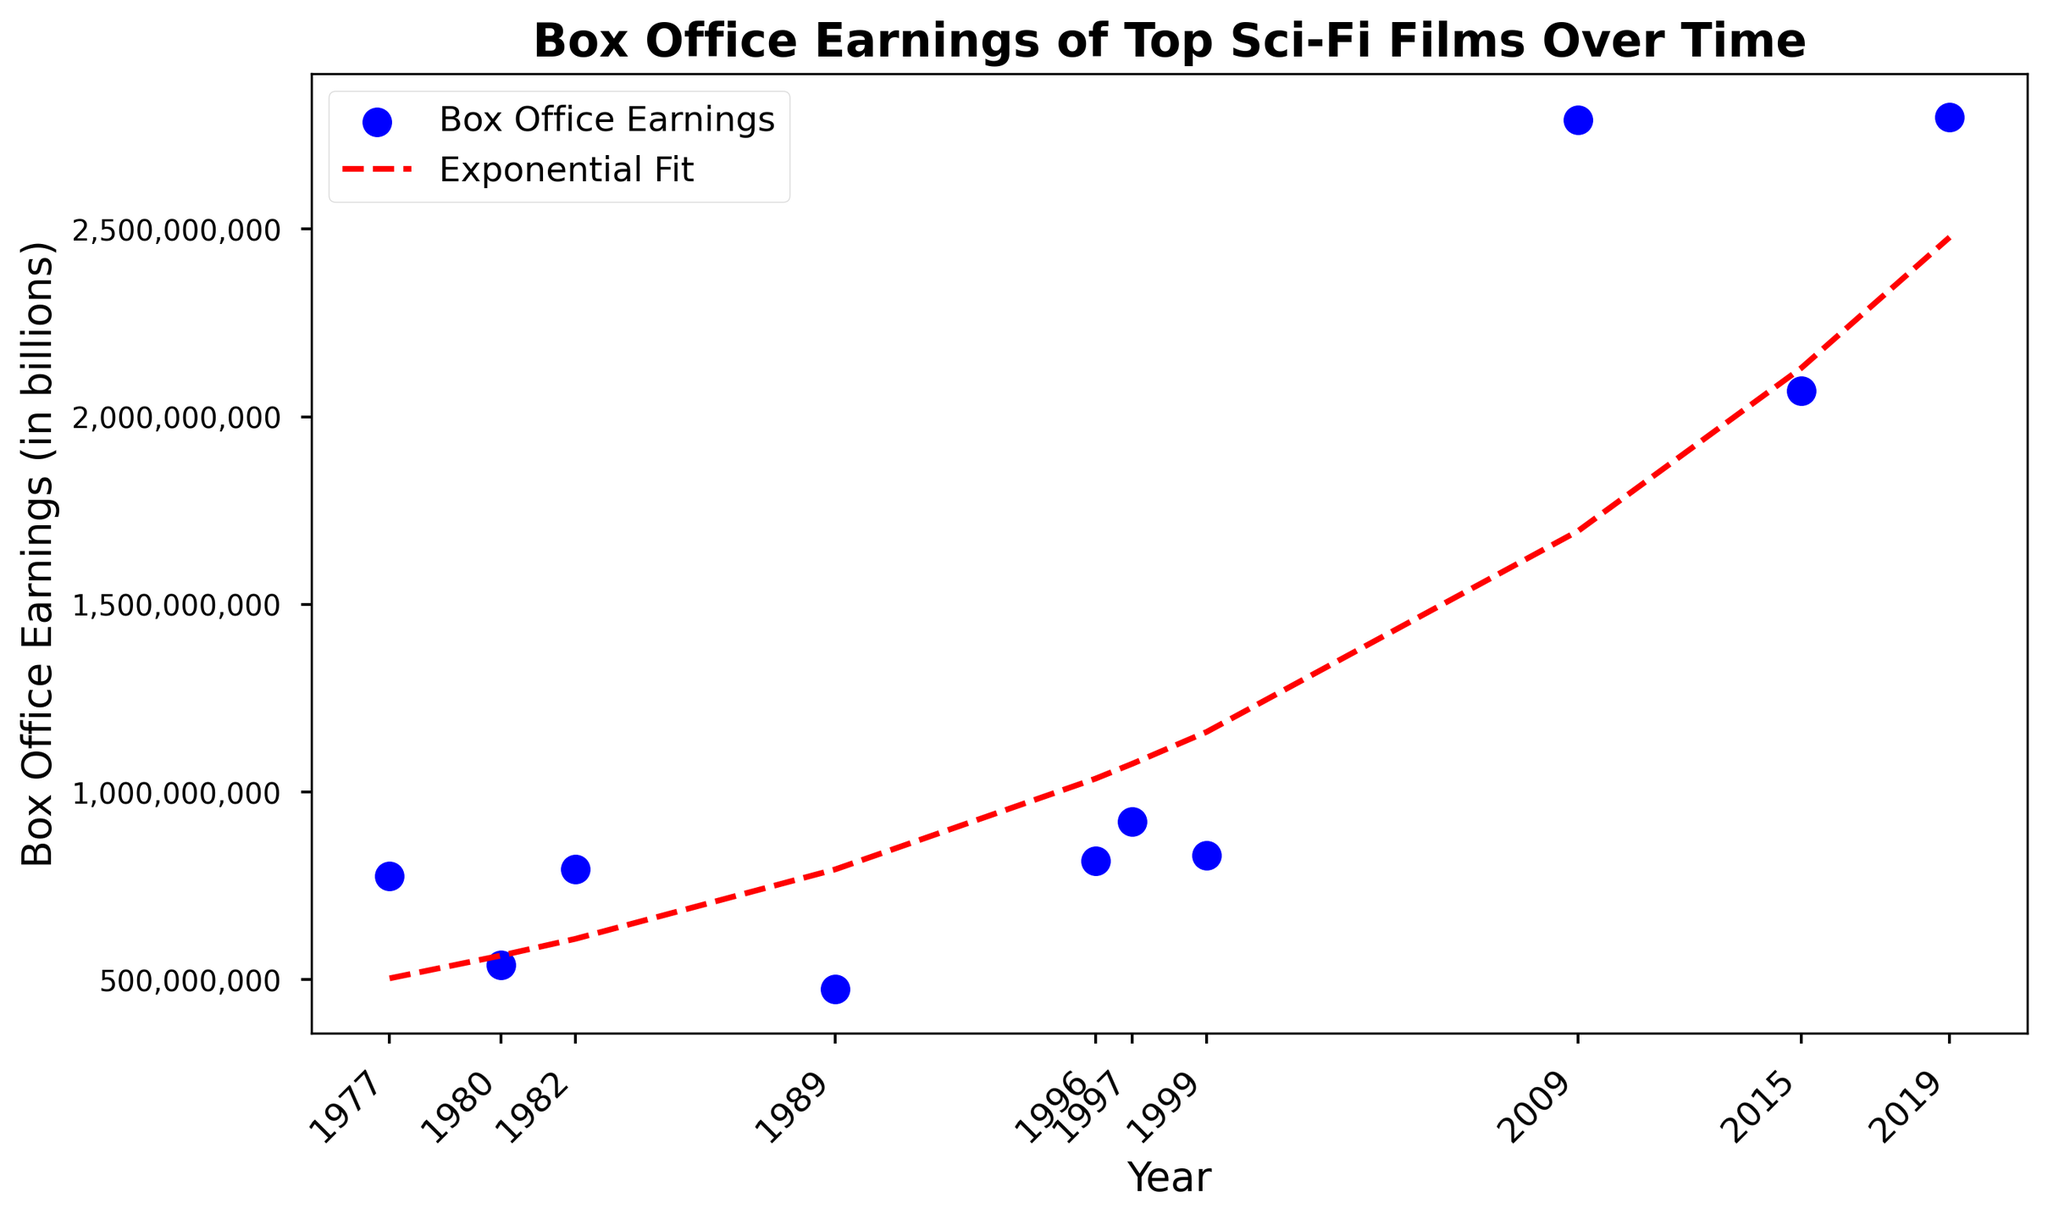What is the total box office earnings for the years 1977 and 1982 combined? Add the earnings of 1977 (775,398,007) to the earnings of 1982 (793,814,567). The calculation is 775,398,007 + 793,814,567 = 1,569,212,574.
Answer: 1,569,212,574 Which year shows the highest box office earnings? Look at the scatter plot and identify the highest point. The highest box office earnings are in 2019, with 2,797,800,564.
Answer: 2019 Is the box office earning in 1989 greater than that in 1980? Compare the earnings for the years 1989 (474,171,806) and 1980 (538,375,067). Since 474,171,806 < 538,375,067, the earnings in 1989 are not greater.
Answer: No What is the trend represented by the red dashed line in the plot? The red dashed line represents the exponential fit to the data points. This suggests that box office earnings for sci-fi films are growing exponentially over time.
Answer: Exponential growth By approximately how much did the box office earnings increase from the year 1999 to 2009? Subtract the box office earnings of 1999 (831,711,189) from that of 2009 (2,790,439,092). The calculation is 2,790,439,092 - 831,711,189 = 1,958,727,903.
Answer: 1,958,727,903 What's the average box office earnings for the movies in the given dataset? Sum all the earnings and then divide by the number of years. The total earnings are 13,360,049,646, for 10 years, so the average is 13,360,049,646 / 10 = 1,336,004,964.6.
Answer: 1,336,004,964.6 Which two years have the largest difference in box office earnings? Compare the earnings between all pairs of years. The largest difference is between 1989 (474,171,806) and 2019 (2,797,800,564), with a difference of 2,323,628,758.
Answer: 1989 and 2019 Do the years with lower box office earnings tend to occur earlier or later in the dataset? Observe the scatter plot to see the distribution of lower earnings. The lower earnings generally occur earlier, starting in the 1970s and 1980s.
Answer: Earlier Is the box office earning trend clearly linear or exponential over the given time period? Look at the fit line on the plot. The line is exponential (as indicated by the red dashed line and the fact that the earnings rise steeply over time).
Answer: Exponential 